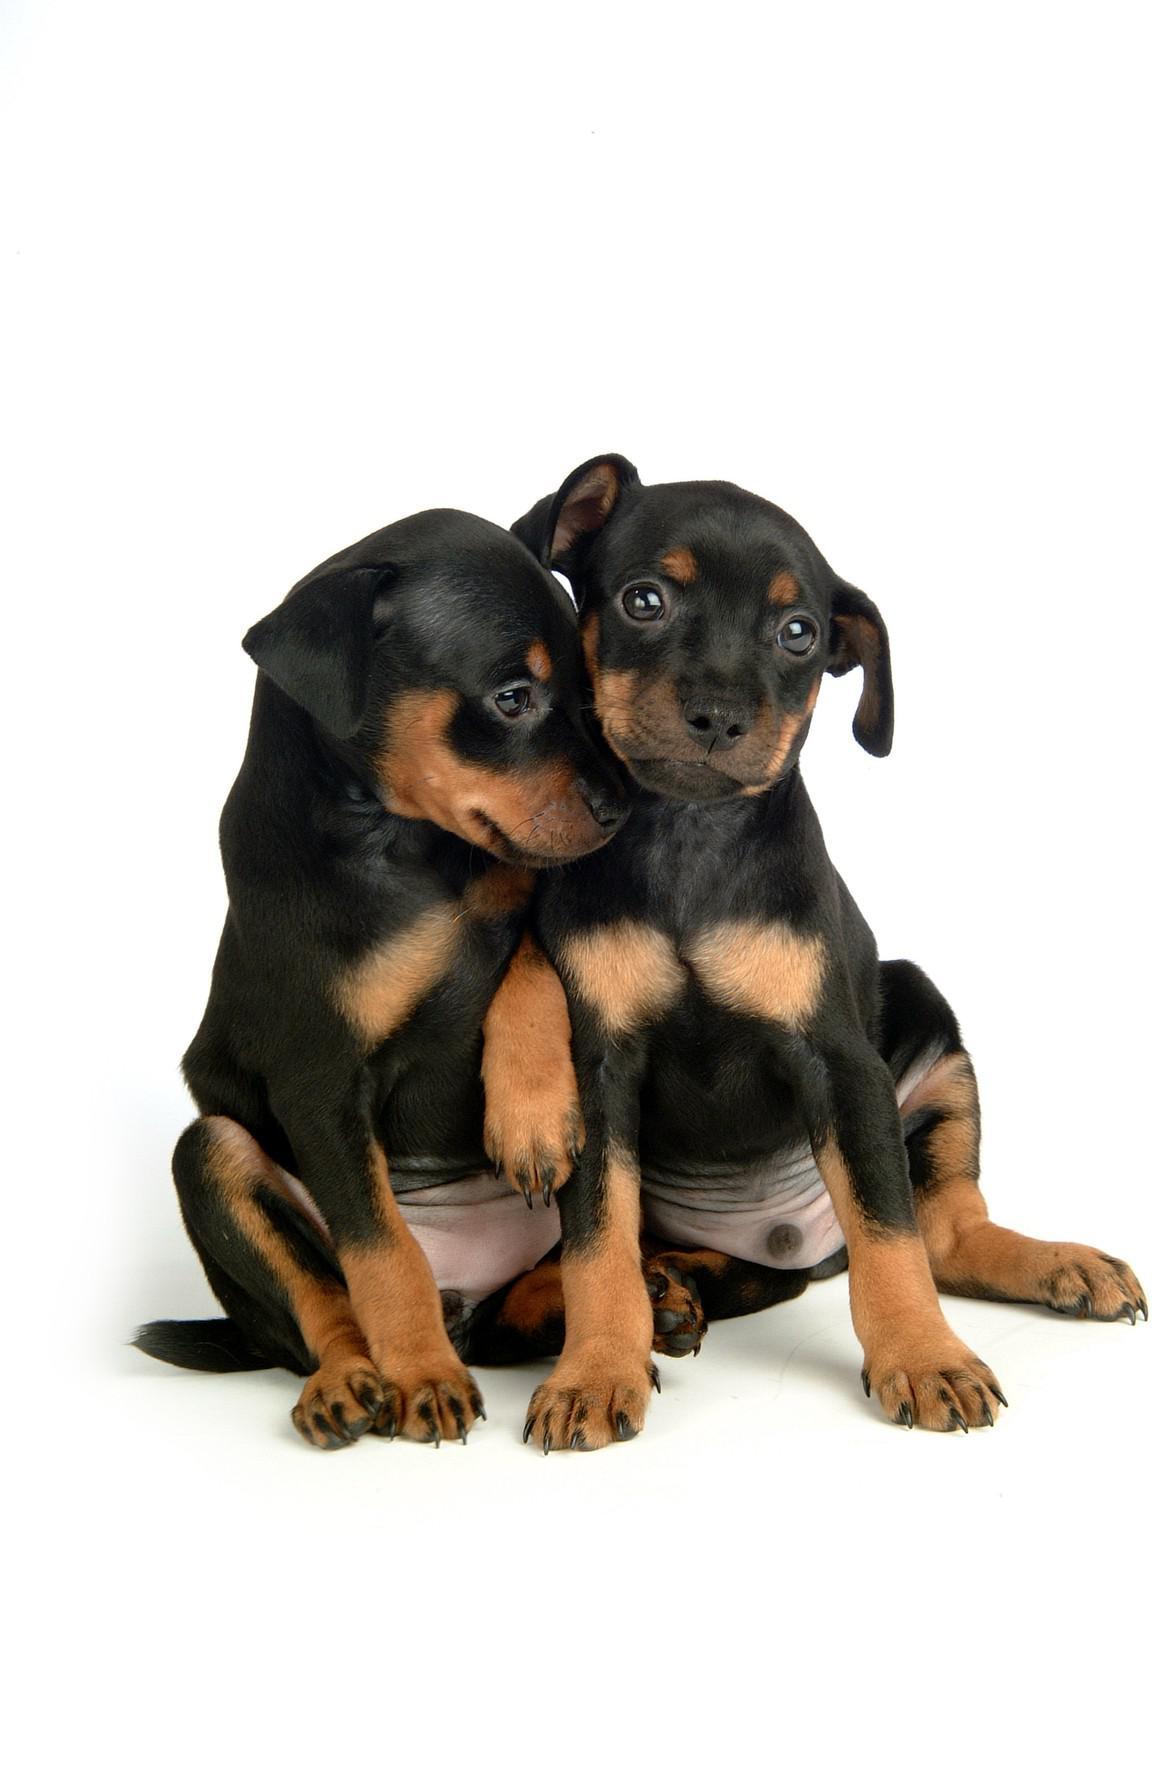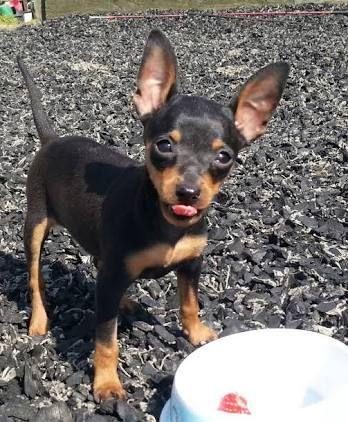The first image is the image on the left, the second image is the image on the right. Assess this claim about the two images: "One image shows a human hand interacting with a juvenile dog.". Correct or not? Answer yes or no. No. The first image is the image on the left, the second image is the image on the right. Assess this claim about the two images: "There is a puppy biting a finger in one of the images.". Correct or not? Answer yes or no. No. 